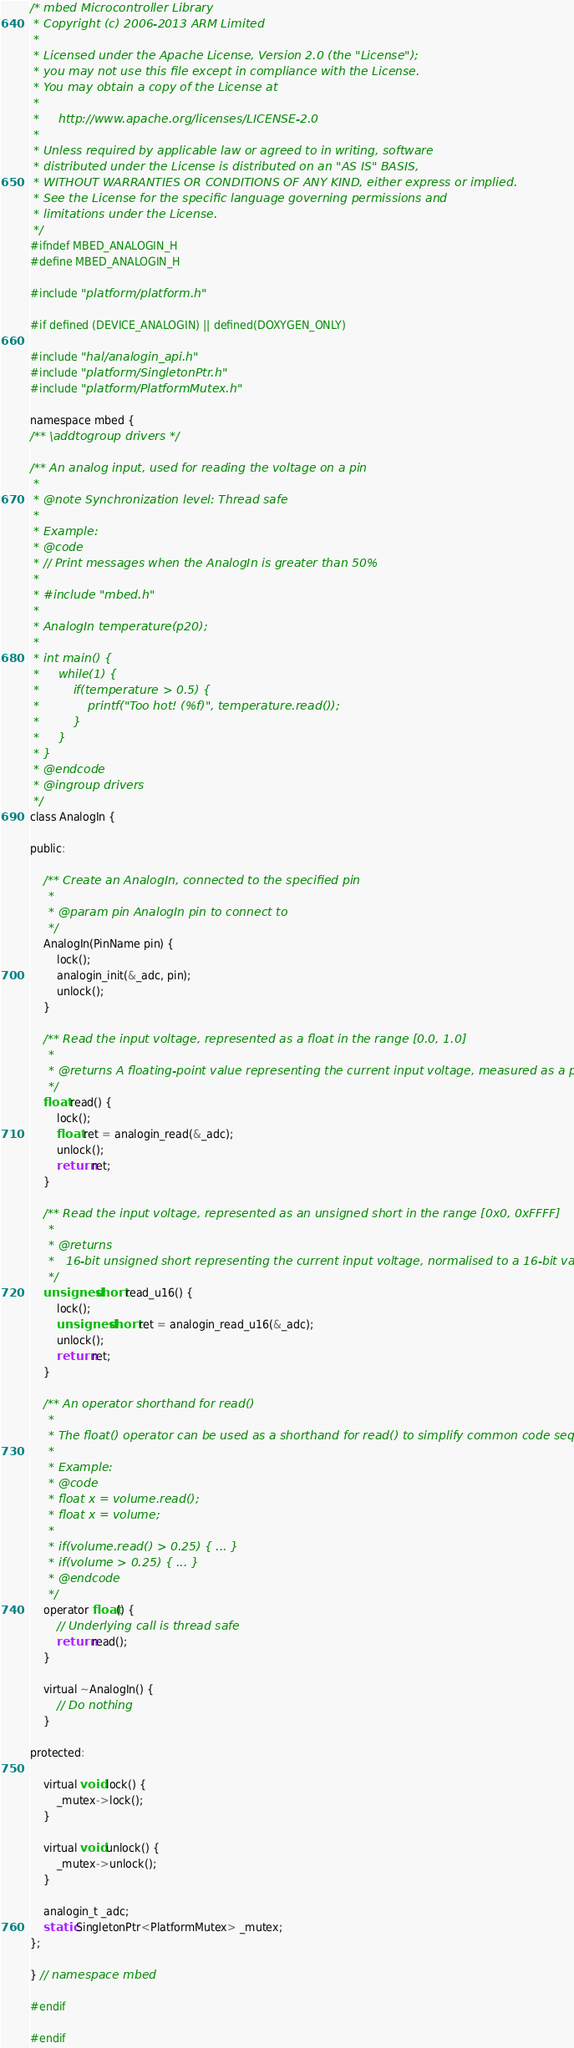<code> <loc_0><loc_0><loc_500><loc_500><_C_>/* mbed Microcontroller Library
 * Copyright (c) 2006-2013 ARM Limited
 *
 * Licensed under the Apache License, Version 2.0 (the "License");
 * you may not use this file except in compliance with the License.
 * You may obtain a copy of the License at
 *
 *     http://www.apache.org/licenses/LICENSE-2.0
 *
 * Unless required by applicable law or agreed to in writing, software
 * distributed under the License is distributed on an "AS IS" BASIS,
 * WITHOUT WARRANTIES OR CONDITIONS OF ANY KIND, either express or implied.
 * See the License for the specific language governing permissions and
 * limitations under the License.
 */
#ifndef MBED_ANALOGIN_H
#define MBED_ANALOGIN_H

#include "platform/platform.h"

#if defined (DEVICE_ANALOGIN) || defined(DOXYGEN_ONLY)

#include "hal/analogin_api.h"
#include "platform/SingletonPtr.h"
#include "platform/PlatformMutex.h"

namespace mbed {
/** \addtogroup drivers */

/** An analog input, used for reading the voltage on a pin
 *
 * @note Synchronization level: Thread safe
 *
 * Example:
 * @code
 * // Print messages when the AnalogIn is greater than 50%
 *
 * #include "mbed.h"
 *
 * AnalogIn temperature(p20);
 *
 * int main() {
 *     while(1) {
 *         if(temperature > 0.5) {
 *             printf("Too hot! (%f)", temperature.read());
 *         }
 *     }
 * }
 * @endcode
 * @ingroup drivers
 */
class AnalogIn {

public:

    /** Create an AnalogIn, connected to the specified pin
     *
     * @param pin AnalogIn pin to connect to
     */
    AnalogIn(PinName pin) {
        lock();
        analogin_init(&_adc, pin);
        unlock();
    }

    /** Read the input voltage, represented as a float in the range [0.0, 1.0]
     *
     * @returns A floating-point value representing the current input voltage, measured as a percentage
     */
    float read() {
        lock();
        float ret = analogin_read(&_adc);
        unlock();
        return ret;
    }

    /** Read the input voltage, represented as an unsigned short in the range [0x0, 0xFFFF]
     *
     * @returns
     *   16-bit unsigned short representing the current input voltage, normalised to a 16-bit value
     */
    unsigned short read_u16() {
        lock();
        unsigned short ret = analogin_read_u16(&_adc);
        unlock();
        return ret;
    }

    /** An operator shorthand for read()
     *
     * The float() operator can be used as a shorthand for read() to simplify common code sequences
     *
     * Example:
     * @code
     * float x = volume.read();
     * float x = volume;
     *
     * if(volume.read() > 0.25) { ... }
     * if(volume > 0.25) { ... }
     * @endcode
     */
    operator float() {
        // Underlying call is thread safe
        return read();
    }

    virtual ~AnalogIn() {
        // Do nothing
    }

protected:

    virtual void lock() {
        _mutex->lock();
    }

    virtual void unlock() {
        _mutex->unlock();
    }

    analogin_t _adc;
    static SingletonPtr<PlatformMutex> _mutex;
};

} // namespace mbed

#endif

#endif

</code> 